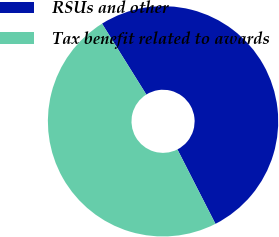Convert chart. <chart><loc_0><loc_0><loc_500><loc_500><pie_chart><fcel>RSUs and other<fcel>Tax benefit related to awards<nl><fcel>51.37%<fcel>48.63%<nl></chart> 